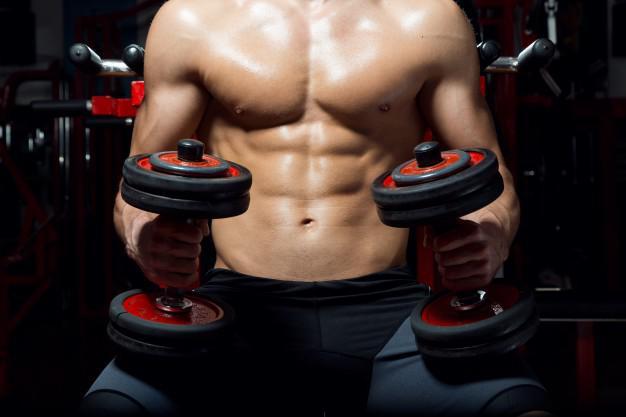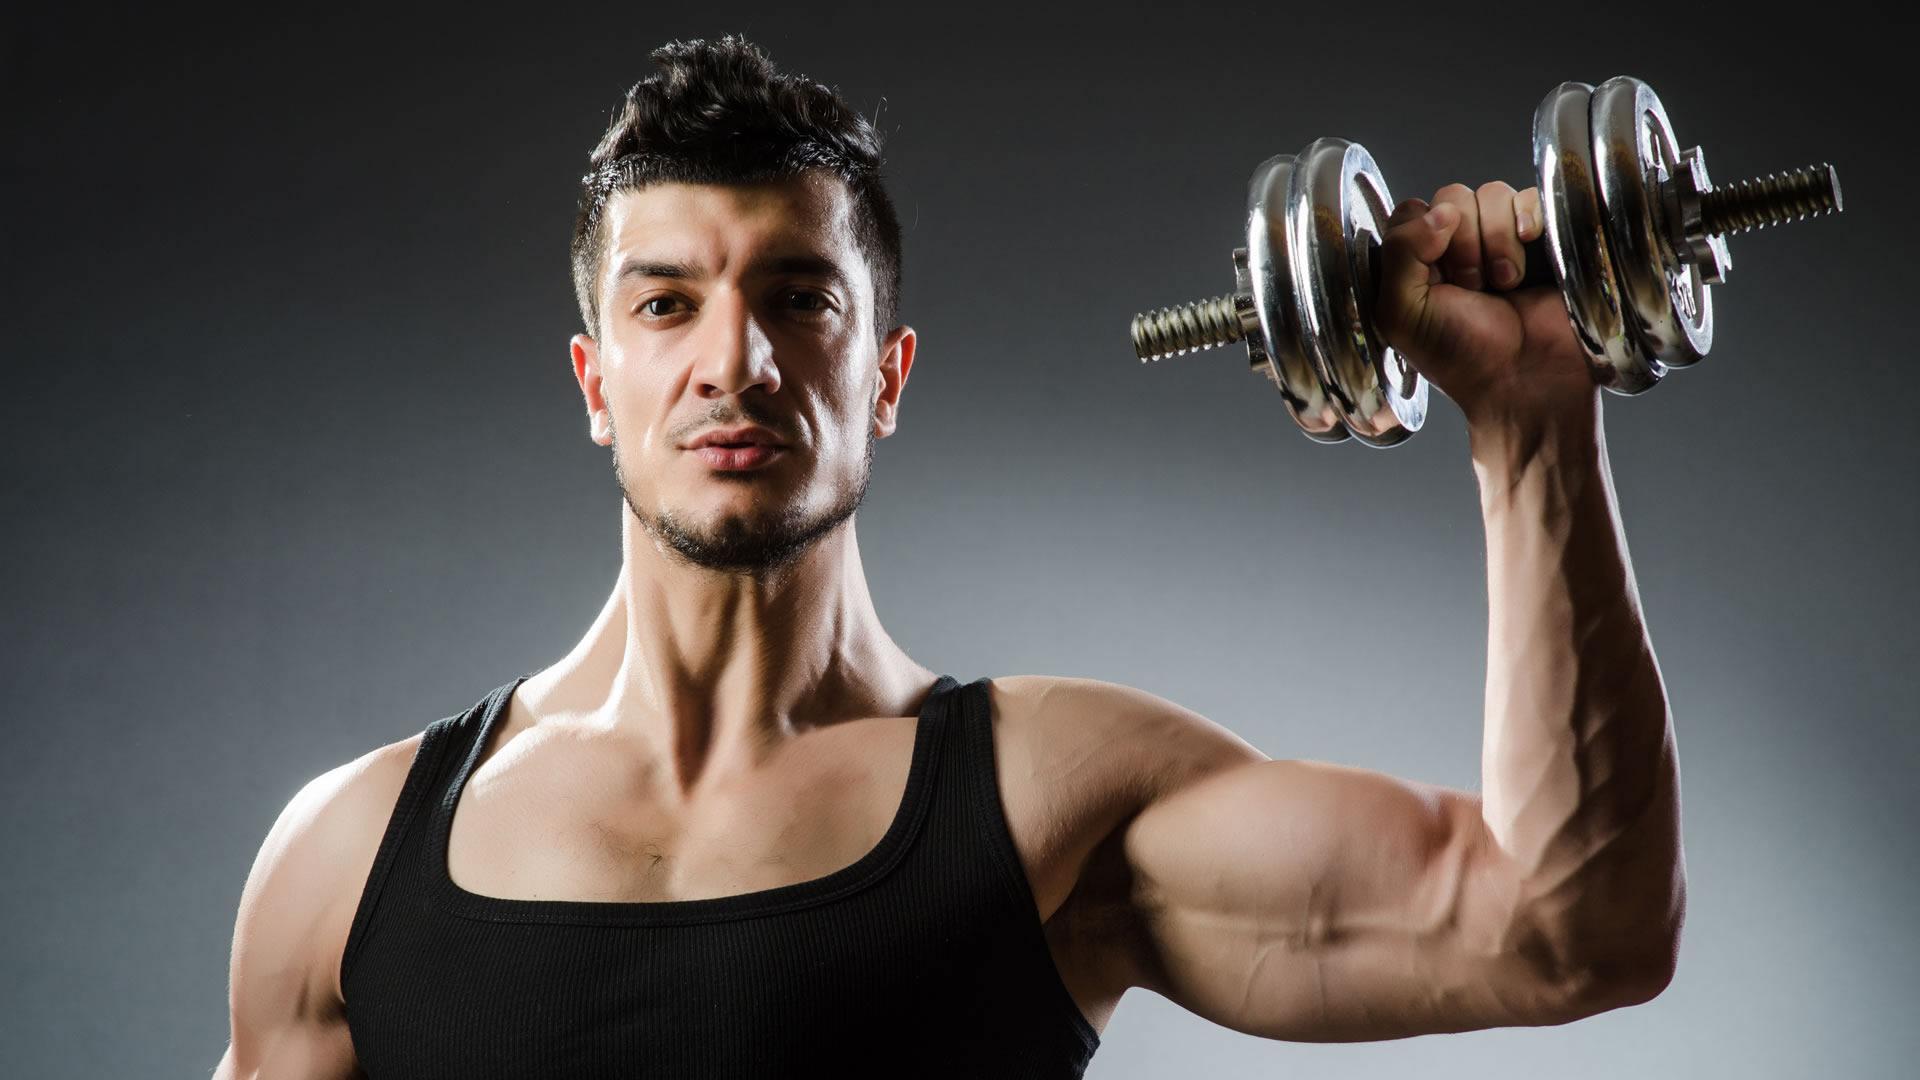The first image is the image on the left, the second image is the image on the right. For the images displayed, is the sentence "The front of a male torso is facing toward the camera in the left image." factually correct? Answer yes or no. Yes. The first image is the image on the left, the second image is the image on the right. Analyze the images presented: Is the assertion "Three dumbbells being held by men are visible." valid? Answer yes or no. Yes. 